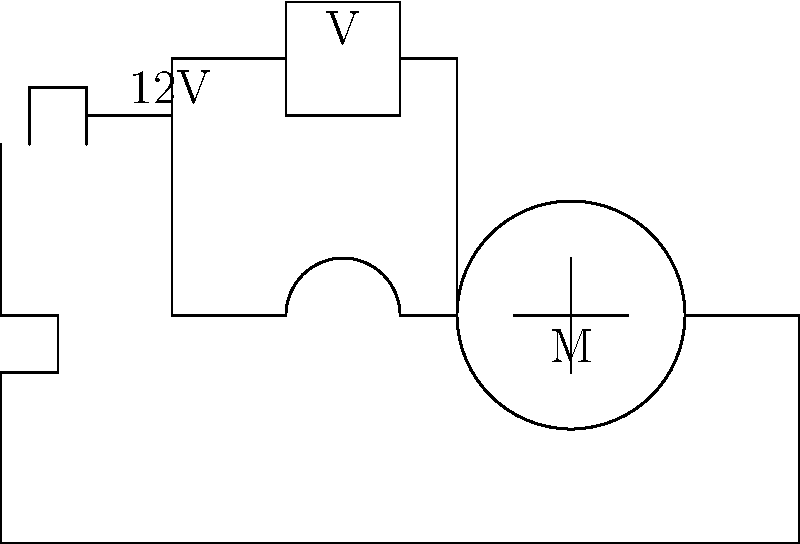In the circuit diagram of a boat's electrical system shown above, what would be the reading on the voltmeter when the switch is open and the motor is not running? To determine the voltmeter reading, let's follow these steps:

1. Identify the components: We have a 12V battery, a switch, a motor, and a voltmeter connected in parallel with the motor.

2. Analyze the circuit when the switch is open:
   - An open switch creates an open circuit, preventing current flow.
   - The motor will not run as it's disconnected from the power source.

3. Understand voltmeter functionality:
   - A voltmeter measures the potential difference between two points in a circuit.
   - It's connected in parallel with the component being measured (in this case, the motor).

4. Apply Kirchhoff's Voltage Law:
   - In an open circuit, the voltage across open switches equals the source voltage.
   - The voltmeter is effectively connected directly across the battery terminals.

5. Consider the battery voltage:
   - The battery provides 12V to the system.

Therefore, when the switch is open, the voltmeter will read the full battery voltage, as there's no voltage drop across other components in the open circuit.
Answer: 12V 